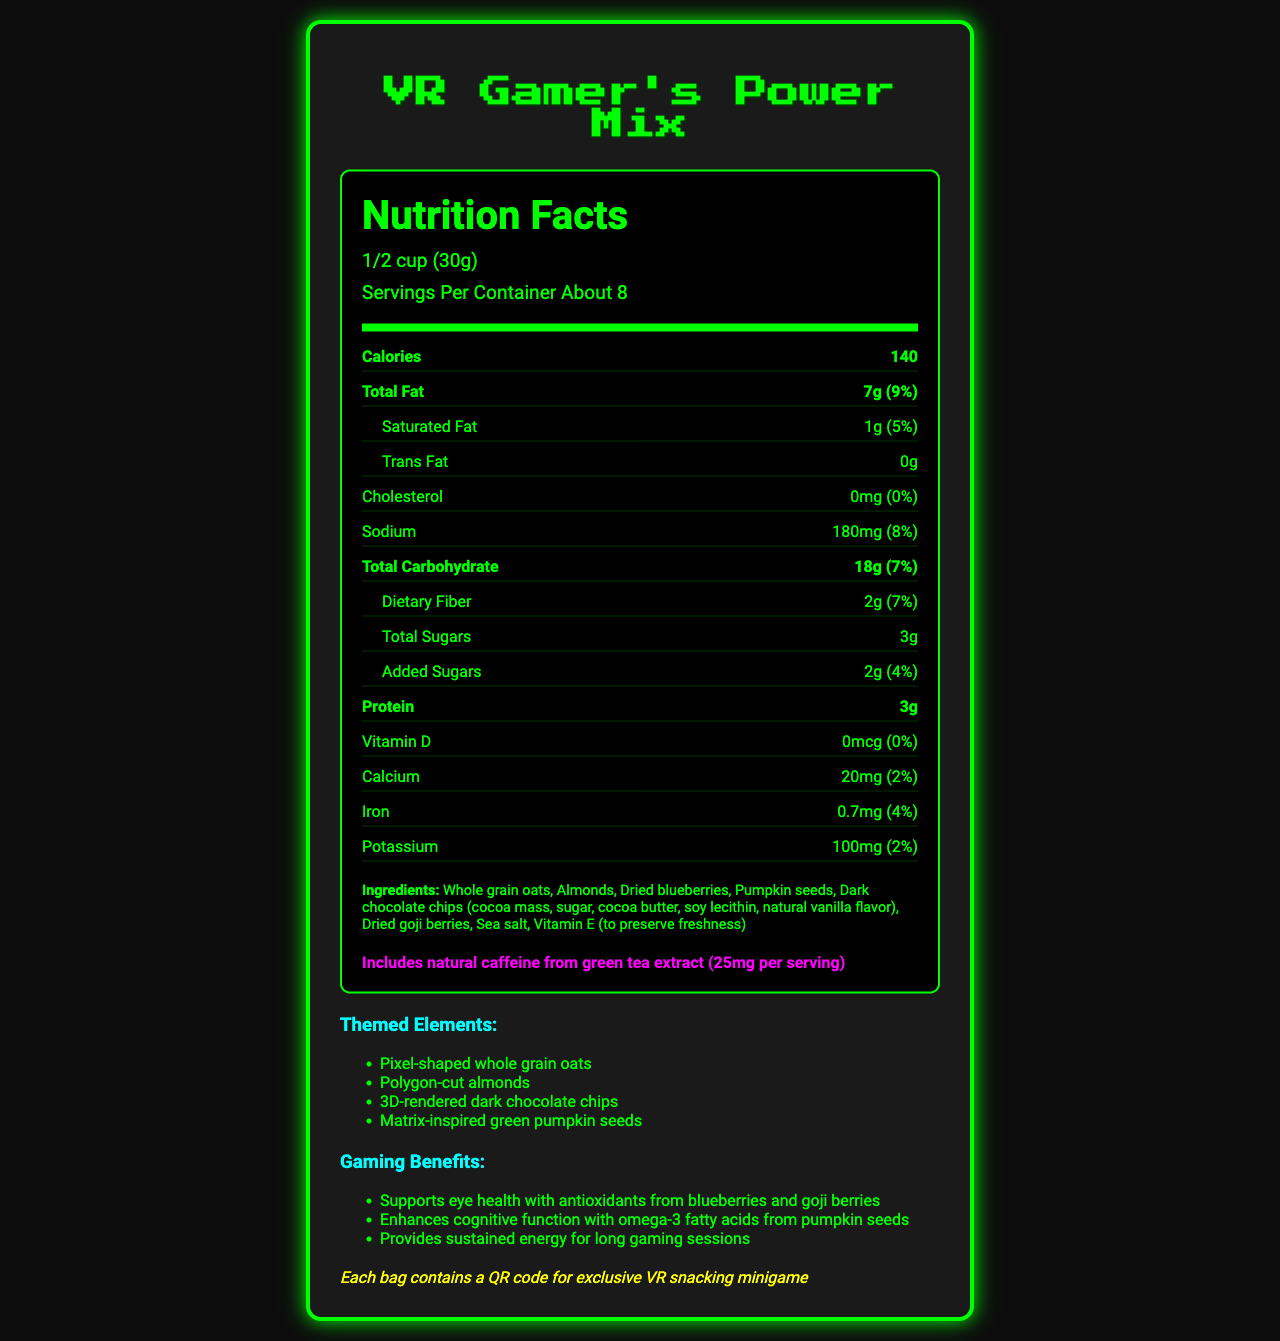what is the serving size? The serving size is listed at the top of the nutrition facts section as "1/2 cup (30g)".
Answer: 1/2 cup (30g) how many calories are in a serving? The calorie content is prominently displayed near the top of the nutrition facts label as "Calories 140".
Answer: 140 how much total fat is in one serving? The total fat is listed in the nutrition facts section as "Total Fat 7g".
Answer: 7g what percentage of the daily value of sodium does one serving contain? The daily value percentage for sodium is listed in the nutrition facts section as "Sodium 180mg (8%)".
Answer: 8% what are the main ingredients in this snack mix? The ingredients are listed at the bottom of the nutrition facts label.
Answer: Whole grain oats, Almonds, Dried blueberries, Pumpkin seeds, Dark chocolate chips, Dried goji berries, Sea salt, Vitamin E approximately how many servings are in each container? The number of servings per container is listed at the top of the nutrition facts section as "Servings Per Container About 8".
Answer: About 8 what is the primary theme of the snack mix? The product is called "VR Gamer's Power Mix" and includes elements like "Pixel-shaped whole grain oats" and a QR code for a VR snacking minigame, indicating a virtual reality/gaming theme.
Answer: Virtual reality/gaming what benefit does the snack mix provide for gamers? A. Supports bone health B. Enhances cognitive function C. Aids digestion The document lists "Enhances cognitive function with omega-3 fatty acids from pumpkin seeds" as a benefit.
Answer: B. Enhances cognitive function how much natural caffeine is included in each serving? The document states "Includes natural caffeine from green tea extract (25mg per serving)".
Answer: 25mg does this product contain any allergens? The product contains almonds and soy and may contain traces of other tree nuts and milk as indicated in the allergen information section.
Answer: Yes are there any added sugars in the snack mix? A. Yes B. No The nutrition facts showing "Added Sugars 2g (4%)" confirm that there are added sugars in the snack mix.
Answer: A. Yes is there any cholesterol in one serving? The nutrition facts list "Cholesterol 0mg (0%)", indicating there is no cholesterol in one serving.
Answer: No describe the **entire document**. The document provides a complete breakdown of nutritional information, ingredients, and additional benefits and themes related to the "VR Gamer's Power Mix". Emphasis is placed on its suitability for gamers and its virtual reality-themed elements.
Answer: The document is a detailed description of the nutrition facts label for a VR-themed snack mix called "VR Gamer's Power Mix". It includes serving size, caloric content, and daily value percentages for various nutrients. Ingredients and allergen information are listed, along with themed elements and benefits for gamers. There is also information about a QR code for a VR snacking minigame. how is the calcium content presented? The calcium content is presented in the nutrition facts section as "Calcium 20mg (2%)".
Answer: 20mg (2%) what is the amount of dietary fiber in one serving? The amount of dietary fiber is listed in the nutrition facts section as "Dietary Fiber 2g".
Answer: 2g which component is not specified in the document? A. Vitamin C B. Vitamin D C. Iron D. Potassium The nutrition facts label lists amounts and daily values for Vitamin D, Iron, and Potassium, but there is no information about Vitamin C.
Answer: A. Vitamin C what cognitive benefit does this snack provide? This benefit is explicitly mentioned in the "Gaming Benefits" section.
Answer: Enhances cognitive function with omega-3 fatty acids from pumpkin seeds can a lactose-intolerant person determine if this product is safe to consume? While the allergen info indicates it may contain traces of milk, it doesn't provide clear enough information for a lactose-intolerant person to make a safe decision.
Answer: Not enough information 